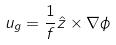<formula> <loc_0><loc_0><loc_500><loc_500>u _ { g } = \frac { 1 } { f } \hat { z } \times \nabla \phi</formula> 